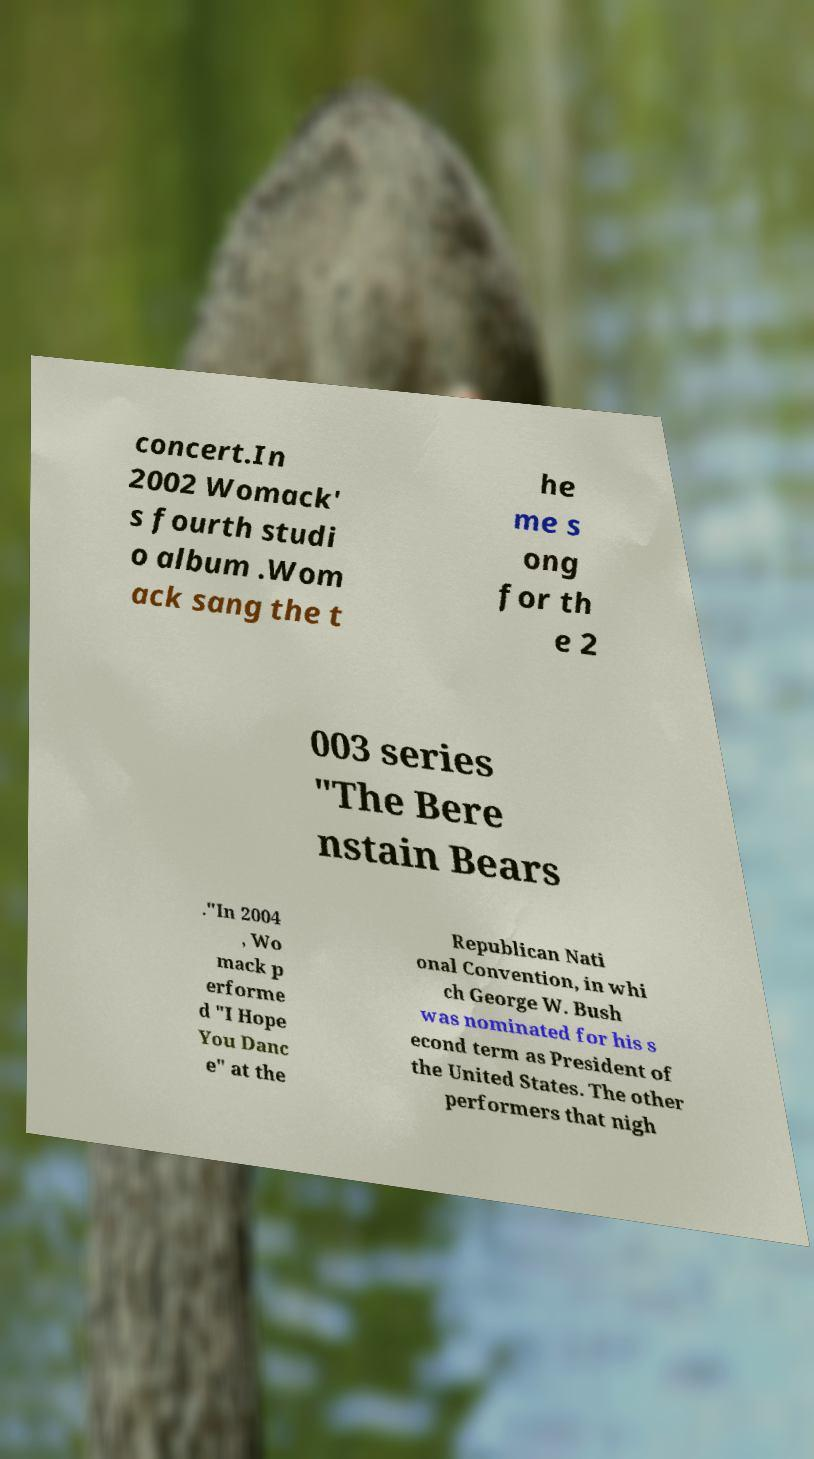Please identify and transcribe the text found in this image. concert.In 2002 Womack' s fourth studi o album .Wom ack sang the t he me s ong for th e 2 003 series "The Bere nstain Bears ."In 2004 , Wo mack p erforme d "I Hope You Danc e" at the Republican Nati onal Convention, in whi ch George W. Bush was nominated for his s econd term as President of the United States. The other performers that nigh 